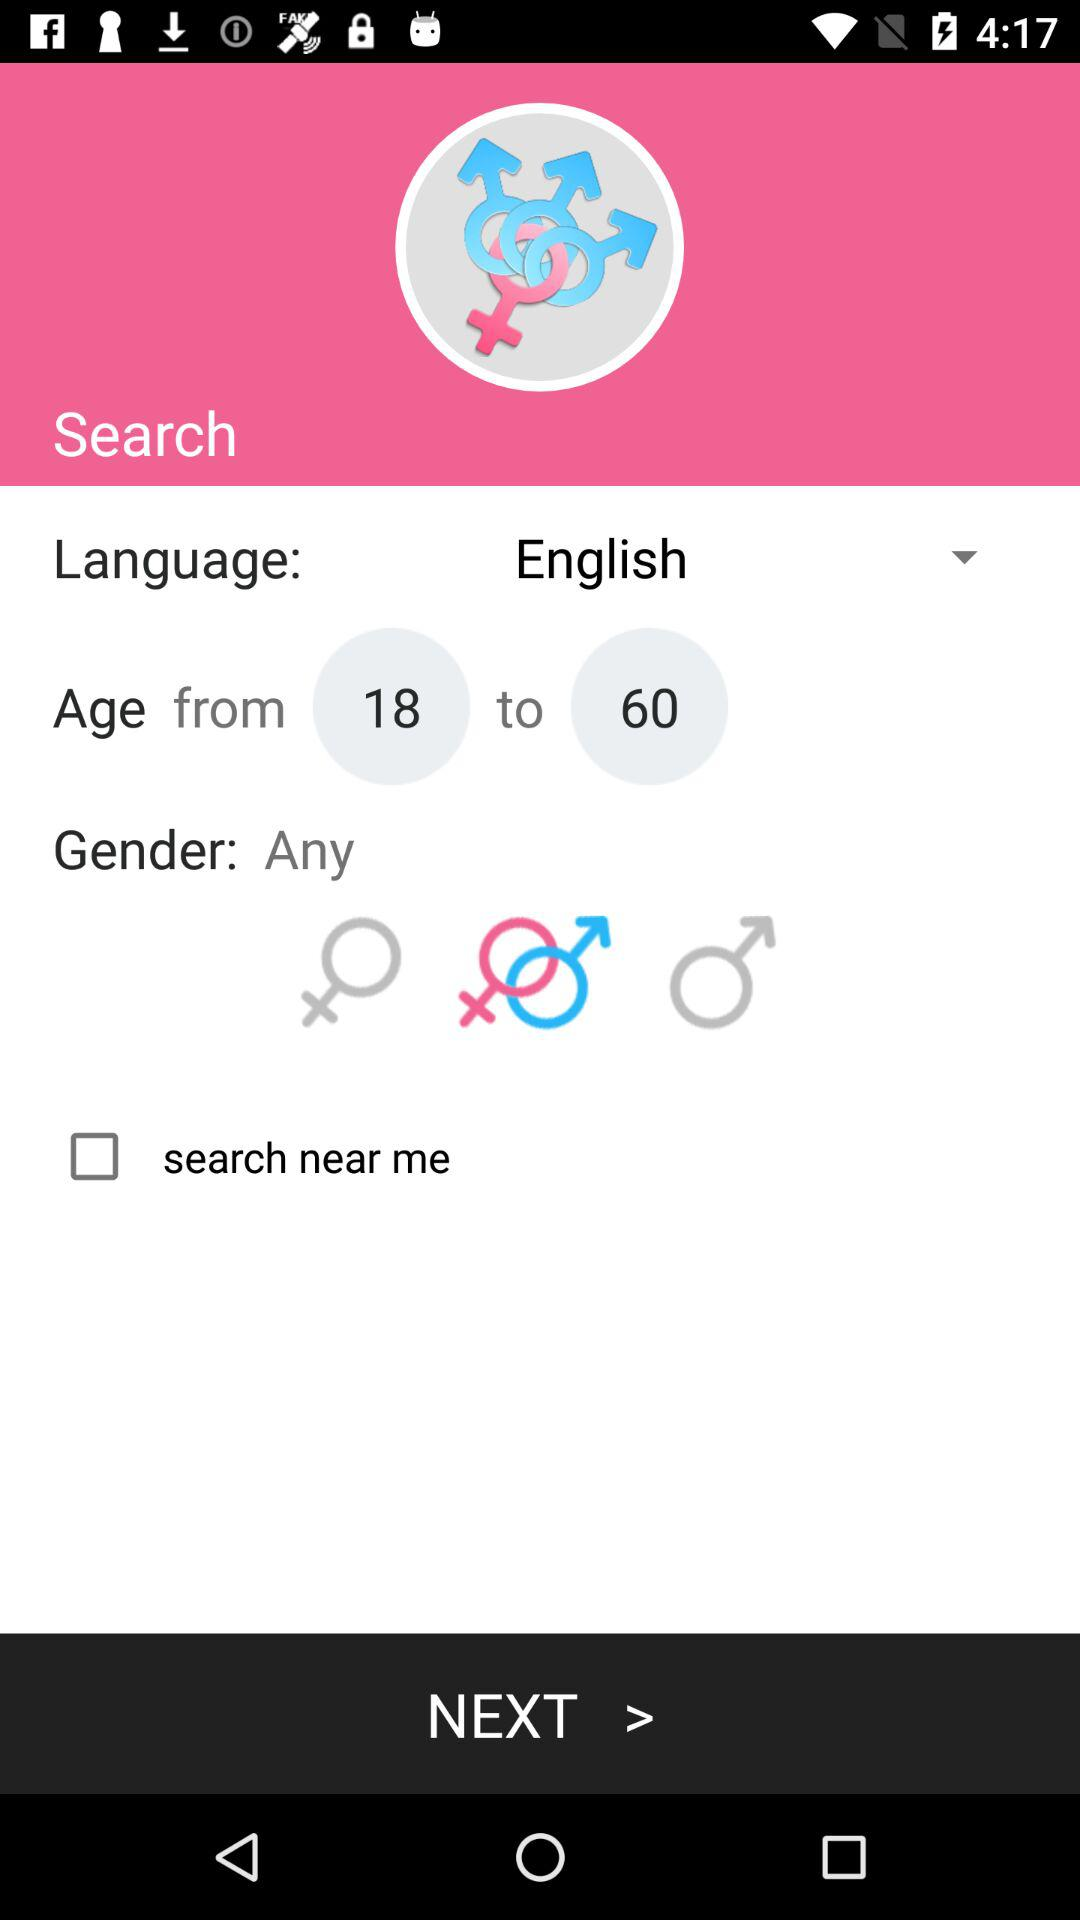What is the difference between the minimum and maximum age for search results?
Answer the question using a single word or phrase. 42 